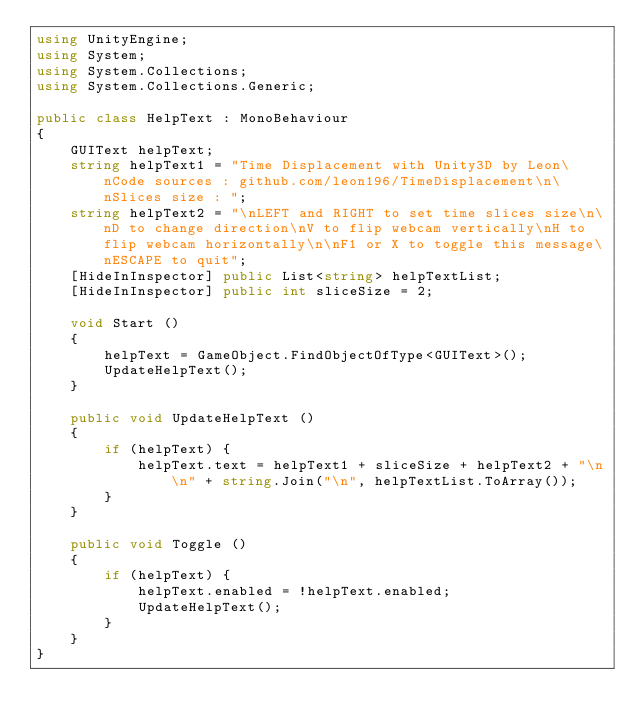<code> <loc_0><loc_0><loc_500><loc_500><_C#_>using UnityEngine;
using System;
using System.Collections;
using System.Collections.Generic;

public class HelpText : MonoBehaviour
{
	GUIText helpText;
	string helpText1 = "Time Displacement with Unity3D by Leon\nCode sources : github.com/leon196/TimeDisplacement\n\nSlices size : ";
	string helpText2 = "\nLEFT and RIGHT to set time slices size\n\nD to change direction\nV to flip webcam vertically\nH to flip webcam horizontally\n\nF1 or X to toggle this message\nESCAPE to quit";
	[HideInInspector] public List<string> helpTextList;
	[HideInInspector] public int sliceSize = 2;

	void Start ()
	{
		helpText = GameObject.FindObjectOfType<GUIText>();
		UpdateHelpText();
	}

	public void UpdateHelpText ()
	{
		if (helpText) {
			helpText.text = helpText1 + sliceSize + helpText2 + "\n\n" + string.Join("\n", helpTextList.ToArray());
		}
	}

	public void Toggle ()
	{
		if (helpText) {
			helpText.enabled = !helpText.enabled;
			UpdateHelpText();
		}
	}
}</code> 